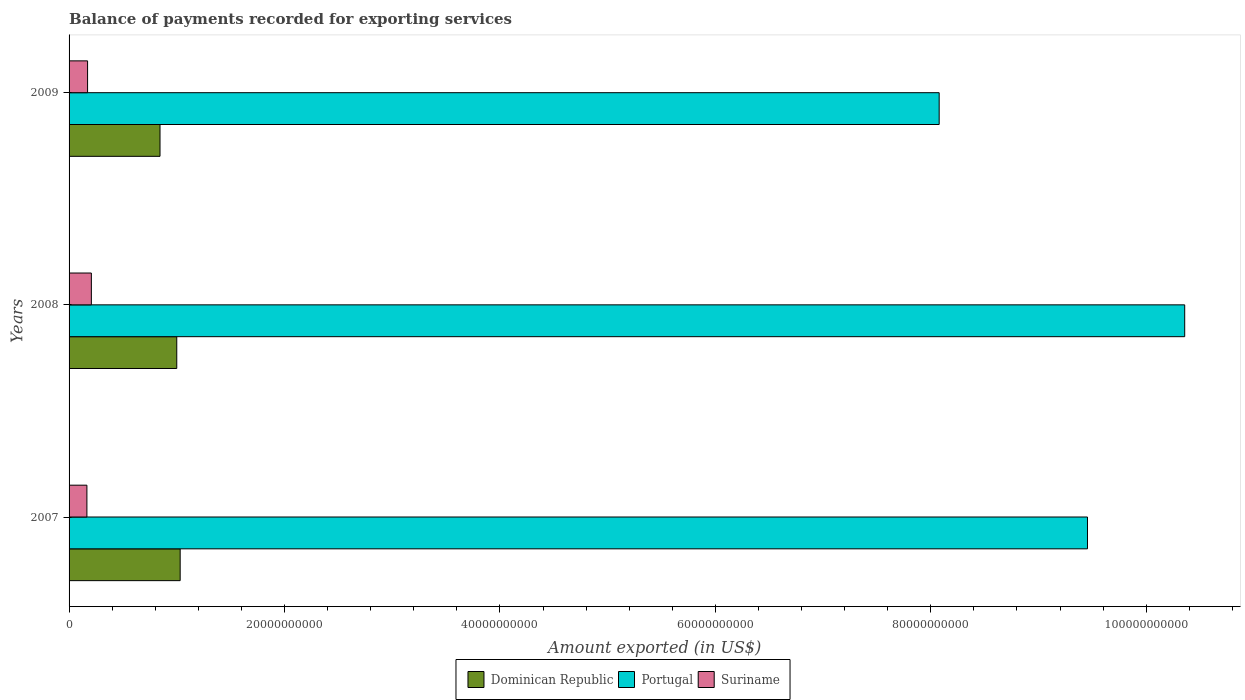How many groups of bars are there?
Your answer should be very brief. 3. Are the number of bars per tick equal to the number of legend labels?
Make the answer very short. Yes. Are the number of bars on each tick of the Y-axis equal?
Provide a succinct answer. Yes. How many bars are there on the 3rd tick from the top?
Offer a terse response. 3. How many bars are there on the 3rd tick from the bottom?
Ensure brevity in your answer.  3. What is the label of the 3rd group of bars from the top?
Make the answer very short. 2007. What is the amount exported in Suriname in 2008?
Offer a terse response. 2.07e+09. Across all years, what is the maximum amount exported in Dominican Republic?
Your answer should be very brief. 1.03e+1. Across all years, what is the minimum amount exported in Dominican Republic?
Provide a succinct answer. 8.44e+09. In which year was the amount exported in Portugal maximum?
Your answer should be very brief. 2008. In which year was the amount exported in Suriname minimum?
Offer a very short reply. 2007. What is the total amount exported in Suriname in the graph?
Provide a short and direct response. 5.44e+09. What is the difference between the amount exported in Portugal in 2007 and that in 2008?
Keep it short and to the point. -9.03e+09. What is the difference between the amount exported in Suriname in 2008 and the amount exported in Dominican Republic in 2007?
Give a very brief answer. -8.24e+09. What is the average amount exported in Suriname per year?
Keep it short and to the point. 1.81e+09. In the year 2007, what is the difference between the amount exported in Suriname and amount exported in Dominican Republic?
Ensure brevity in your answer.  -8.66e+09. In how many years, is the amount exported in Portugal greater than 100000000000 US$?
Ensure brevity in your answer.  1. What is the ratio of the amount exported in Suriname in 2008 to that in 2009?
Offer a very short reply. 1.2. What is the difference between the highest and the second highest amount exported in Suriname?
Offer a very short reply. 3.52e+08. What is the difference between the highest and the lowest amount exported in Dominican Republic?
Your answer should be very brief. 1.87e+09. In how many years, is the amount exported in Portugal greater than the average amount exported in Portugal taken over all years?
Make the answer very short. 2. Is the sum of the amount exported in Suriname in 2008 and 2009 greater than the maximum amount exported in Portugal across all years?
Provide a short and direct response. No. What does the 3rd bar from the bottom in 2009 represents?
Keep it short and to the point. Suriname. Is it the case that in every year, the sum of the amount exported in Dominican Republic and amount exported in Suriname is greater than the amount exported in Portugal?
Ensure brevity in your answer.  No. Are all the bars in the graph horizontal?
Your answer should be compact. Yes. Are the values on the major ticks of X-axis written in scientific E-notation?
Your answer should be very brief. No. Does the graph contain grids?
Your response must be concise. No. Where does the legend appear in the graph?
Your answer should be compact. Bottom center. How many legend labels are there?
Provide a short and direct response. 3. What is the title of the graph?
Your answer should be very brief. Balance of payments recorded for exporting services. Does "Arab World" appear as one of the legend labels in the graph?
Ensure brevity in your answer.  No. What is the label or title of the X-axis?
Make the answer very short. Amount exported (in US$). What is the label or title of the Y-axis?
Offer a very short reply. Years. What is the Amount exported (in US$) in Dominican Republic in 2007?
Offer a very short reply. 1.03e+1. What is the Amount exported (in US$) in Portugal in 2007?
Offer a terse response. 9.45e+1. What is the Amount exported (in US$) in Suriname in 2007?
Ensure brevity in your answer.  1.66e+09. What is the Amount exported (in US$) in Dominican Republic in 2008?
Offer a terse response. 1.00e+1. What is the Amount exported (in US$) in Portugal in 2008?
Ensure brevity in your answer.  1.04e+11. What is the Amount exported (in US$) in Suriname in 2008?
Provide a short and direct response. 2.07e+09. What is the Amount exported (in US$) of Dominican Republic in 2009?
Offer a terse response. 8.44e+09. What is the Amount exported (in US$) of Portugal in 2009?
Provide a short and direct response. 8.08e+1. What is the Amount exported (in US$) in Suriname in 2009?
Provide a succinct answer. 1.72e+09. Across all years, what is the maximum Amount exported (in US$) in Dominican Republic?
Provide a succinct answer. 1.03e+1. Across all years, what is the maximum Amount exported (in US$) in Portugal?
Give a very brief answer. 1.04e+11. Across all years, what is the maximum Amount exported (in US$) in Suriname?
Ensure brevity in your answer.  2.07e+09. Across all years, what is the minimum Amount exported (in US$) in Dominican Republic?
Keep it short and to the point. 8.44e+09. Across all years, what is the minimum Amount exported (in US$) of Portugal?
Make the answer very short. 8.08e+1. Across all years, what is the minimum Amount exported (in US$) in Suriname?
Your answer should be very brief. 1.66e+09. What is the total Amount exported (in US$) in Dominican Republic in the graph?
Ensure brevity in your answer.  2.88e+1. What is the total Amount exported (in US$) of Portugal in the graph?
Give a very brief answer. 2.79e+11. What is the total Amount exported (in US$) of Suriname in the graph?
Provide a succinct answer. 5.44e+09. What is the difference between the Amount exported (in US$) in Dominican Republic in 2007 and that in 2008?
Keep it short and to the point. 3.16e+08. What is the difference between the Amount exported (in US$) in Portugal in 2007 and that in 2008?
Your answer should be compact. -9.03e+09. What is the difference between the Amount exported (in US$) of Suriname in 2007 and that in 2008?
Provide a succinct answer. -4.14e+08. What is the difference between the Amount exported (in US$) of Dominican Republic in 2007 and that in 2009?
Offer a terse response. 1.87e+09. What is the difference between the Amount exported (in US$) of Portugal in 2007 and that in 2009?
Ensure brevity in your answer.  1.38e+1. What is the difference between the Amount exported (in US$) of Suriname in 2007 and that in 2009?
Ensure brevity in your answer.  -6.23e+07. What is the difference between the Amount exported (in US$) of Dominican Republic in 2008 and that in 2009?
Ensure brevity in your answer.  1.56e+09. What is the difference between the Amount exported (in US$) of Portugal in 2008 and that in 2009?
Your answer should be compact. 2.28e+1. What is the difference between the Amount exported (in US$) in Suriname in 2008 and that in 2009?
Your response must be concise. 3.52e+08. What is the difference between the Amount exported (in US$) of Dominican Republic in 2007 and the Amount exported (in US$) of Portugal in 2008?
Ensure brevity in your answer.  -9.33e+1. What is the difference between the Amount exported (in US$) in Dominican Republic in 2007 and the Amount exported (in US$) in Suriname in 2008?
Keep it short and to the point. 8.24e+09. What is the difference between the Amount exported (in US$) in Portugal in 2007 and the Amount exported (in US$) in Suriname in 2008?
Offer a very short reply. 9.25e+1. What is the difference between the Amount exported (in US$) of Dominican Republic in 2007 and the Amount exported (in US$) of Portugal in 2009?
Offer a very short reply. -7.05e+1. What is the difference between the Amount exported (in US$) in Dominican Republic in 2007 and the Amount exported (in US$) in Suriname in 2009?
Ensure brevity in your answer.  8.60e+09. What is the difference between the Amount exported (in US$) in Portugal in 2007 and the Amount exported (in US$) in Suriname in 2009?
Keep it short and to the point. 9.28e+1. What is the difference between the Amount exported (in US$) of Dominican Republic in 2008 and the Amount exported (in US$) of Portugal in 2009?
Give a very brief answer. -7.08e+1. What is the difference between the Amount exported (in US$) of Dominican Republic in 2008 and the Amount exported (in US$) of Suriname in 2009?
Offer a terse response. 8.28e+09. What is the difference between the Amount exported (in US$) of Portugal in 2008 and the Amount exported (in US$) of Suriname in 2009?
Provide a succinct answer. 1.02e+11. What is the average Amount exported (in US$) in Dominican Republic per year?
Keep it short and to the point. 9.59e+09. What is the average Amount exported (in US$) of Portugal per year?
Offer a terse response. 9.30e+1. What is the average Amount exported (in US$) in Suriname per year?
Ensure brevity in your answer.  1.81e+09. In the year 2007, what is the difference between the Amount exported (in US$) of Dominican Republic and Amount exported (in US$) of Portugal?
Your answer should be very brief. -8.42e+1. In the year 2007, what is the difference between the Amount exported (in US$) in Dominican Republic and Amount exported (in US$) in Suriname?
Your response must be concise. 8.66e+09. In the year 2007, what is the difference between the Amount exported (in US$) in Portugal and Amount exported (in US$) in Suriname?
Offer a very short reply. 9.29e+1. In the year 2008, what is the difference between the Amount exported (in US$) of Dominican Republic and Amount exported (in US$) of Portugal?
Keep it short and to the point. -9.36e+1. In the year 2008, what is the difference between the Amount exported (in US$) in Dominican Republic and Amount exported (in US$) in Suriname?
Keep it short and to the point. 7.93e+09. In the year 2008, what is the difference between the Amount exported (in US$) of Portugal and Amount exported (in US$) of Suriname?
Make the answer very short. 1.02e+11. In the year 2009, what is the difference between the Amount exported (in US$) in Dominican Republic and Amount exported (in US$) in Portugal?
Keep it short and to the point. -7.23e+1. In the year 2009, what is the difference between the Amount exported (in US$) in Dominican Republic and Amount exported (in US$) in Suriname?
Provide a succinct answer. 6.73e+09. In the year 2009, what is the difference between the Amount exported (in US$) in Portugal and Amount exported (in US$) in Suriname?
Ensure brevity in your answer.  7.91e+1. What is the ratio of the Amount exported (in US$) in Dominican Republic in 2007 to that in 2008?
Give a very brief answer. 1.03. What is the ratio of the Amount exported (in US$) of Portugal in 2007 to that in 2008?
Provide a succinct answer. 0.91. What is the ratio of the Amount exported (in US$) in Dominican Republic in 2007 to that in 2009?
Offer a terse response. 1.22. What is the ratio of the Amount exported (in US$) in Portugal in 2007 to that in 2009?
Provide a succinct answer. 1.17. What is the ratio of the Amount exported (in US$) of Suriname in 2007 to that in 2009?
Ensure brevity in your answer.  0.96. What is the ratio of the Amount exported (in US$) of Dominican Republic in 2008 to that in 2009?
Provide a succinct answer. 1.18. What is the ratio of the Amount exported (in US$) in Portugal in 2008 to that in 2009?
Your response must be concise. 1.28. What is the ratio of the Amount exported (in US$) in Suriname in 2008 to that in 2009?
Provide a short and direct response. 1.2. What is the difference between the highest and the second highest Amount exported (in US$) in Dominican Republic?
Your answer should be compact. 3.16e+08. What is the difference between the highest and the second highest Amount exported (in US$) in Portugal?
Provide a succinct answer. 9.03e+09. What is the difference between the highest and the second highest Amount exported (in US$) in Suriname?
Your answer should be compact. 3.52e+08. What is the difference between the highest and the lowest Amount exported (in US$) in Dominican Republic?
Keep it short and to the point. 1.87e+09. What is the difference between the highest and the lowest Amount exported (in US$) in Portugal?
Make the answer very short. 2.28e+1. What is the difference between the highest and the lowest Amount exported (in US$) of Suriname?
Keep it short and to the point. 4.14e+08. 